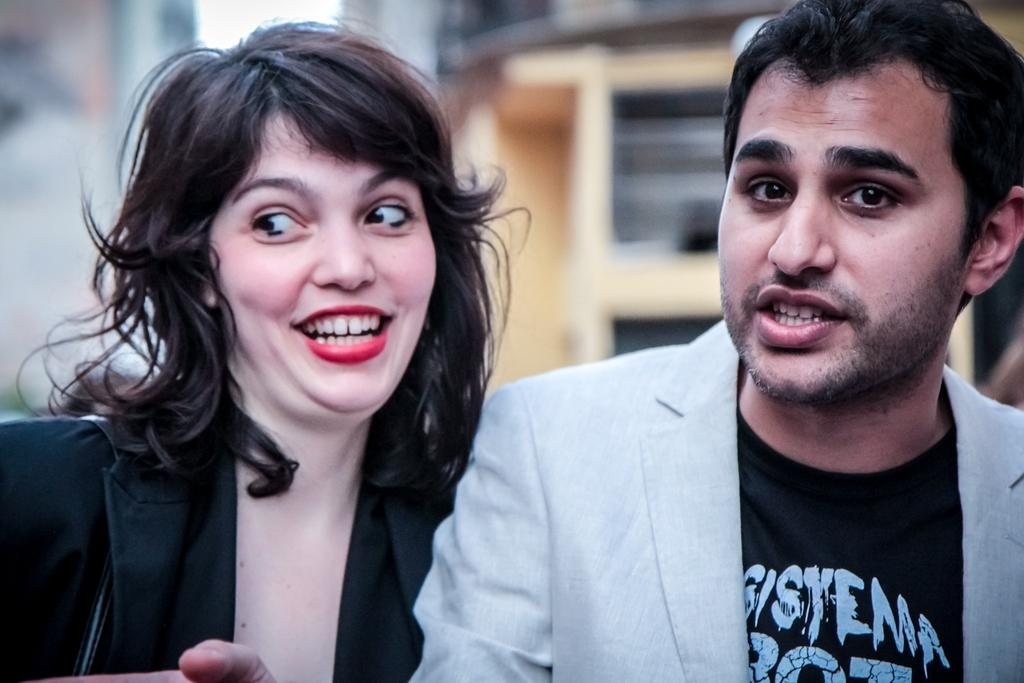Who is present in the image? There is a woman in the image. What is the woman wearing? The woman is wearing a black jacket. Can you describe another person in the image? There is a person wearing a suit in the image. What can be seen in the background of the image? There are buildings visible in the background of the image. How many boats are visible in the image? There are no boats present in the image. What type of cake is the woman holding in the image? There is no cake present in the image. 